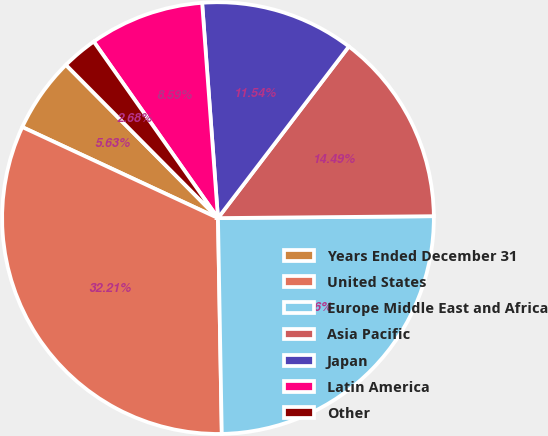Convert chart. <chart><loc_0><loc_0><loc_500><loc_500><pie_chart><fcel>Years Ended December 31<fcel>United States<fcel>Europe Middle East and Africa<fcel>Asia Pacific<fcel>Japan<fcel>Latin America<fcel>Other<nl><fcel>5.63%<fcel>32.21%<fcel>24.86%<fcel>14.49%<fcel>11.54%<fcel>8.59%<fcel>2.68%<nl></chart> 